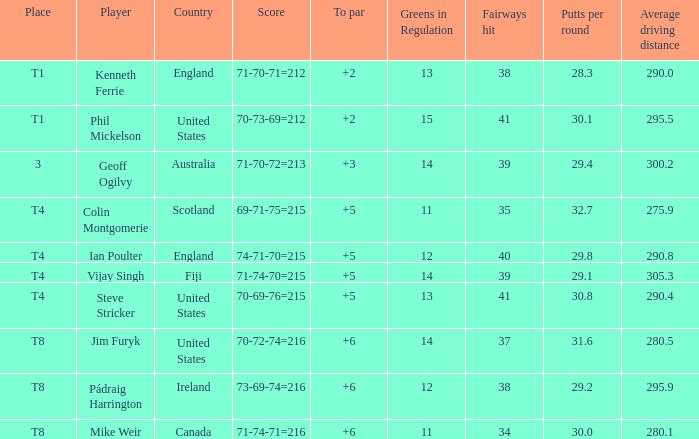What score to highest to par did Mike Weir achieve? 6.0. 